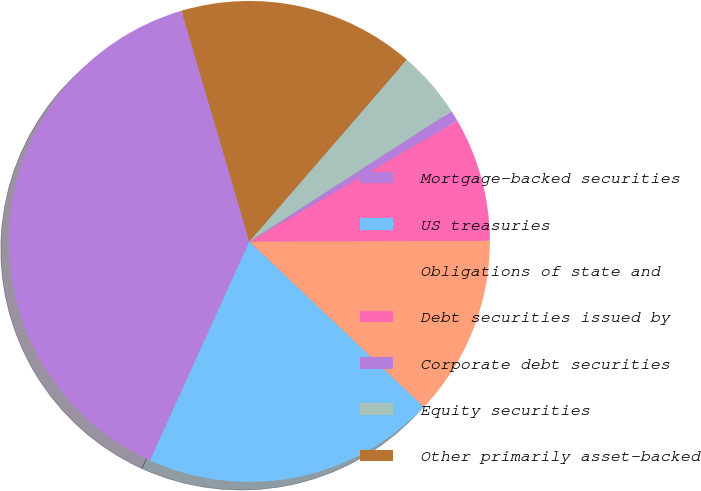Convert chart to OTSL. <chart><loc_0><loc_0><loc_500><loc_500><pie_chart><fcel>Mortgage-backed securities<fcel>US treasuries<fcel>Obligations of state and<fcel>Debt securities issued by<fcel>Corporate debt securities<fcel>Equity securities<fcel>Other primarily asset-backed<nl><fcel>38.66%<fcel>19.7%<fcel>12.12%<fcel>8.33%<fcel>0.74%<fcel>4.53%<fcel>15.91%<nl></chart> 